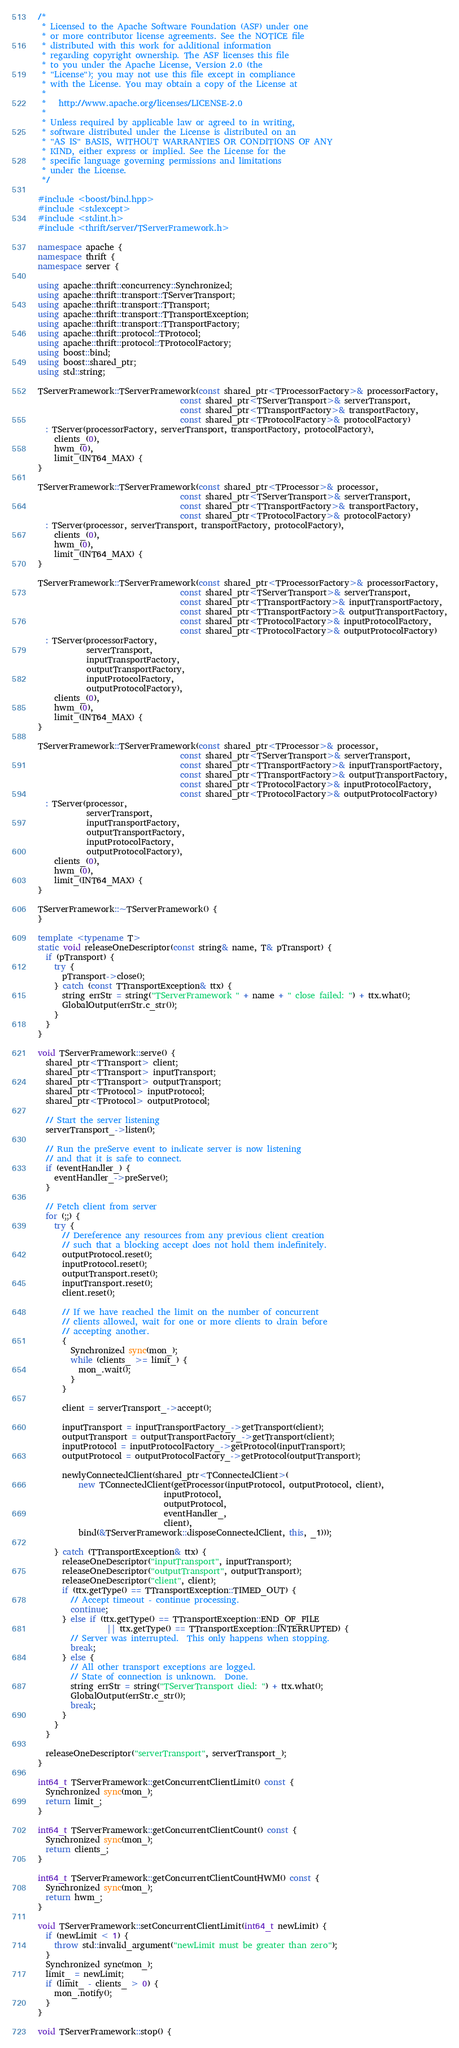Convert code to text. <code><loc_0><loc_0><loc_500><loc_500><_C++_>/*
 * Licensed to the Apache Software Foundation (ASF) under one
 * or more contributor license agreements. See the NOTICE file
 * distributed with this work for additional information
 * regarding copyright ownership. The ASF licenses this file
 * to you under the Apache License, Version 2.0 (the
 * "License"); you may not use this file except in compliance
 * with the License. You may obtain a copy of the License at
 *
 *   http://www.apache.org/licenses/LICENSE-2.0
 *
 * Unless required by applicable law or agreed to in writing,
 * software distributed under the License is distributed on an
 * "AS IS" BASIS, WITHOUT WARRANTIES OR CONDITIONS OF ANY
 * KIND, either express or implied. See the License for the
 * specific language governing permissions and limitations
 * under the License.
 */

#include <boost/bind.hpp>
#include <stdexcept>
#include <stdint.h>
#include <thrift/server/TServerFramework.h>

namespace apache {
namespace thrift {
namespace server {

using apache::thrift::concurrency::Synchronized;
using apache::thrift::transport::TServerTransport;
using apache::thrift::transport::TTransport;
using apache::thrift::transport::TTransportException;
using apache::thrift::transport::TTransportFactory;
using apache::thrift::protocol::TProtocol;
using apache::thrift::protocol::TProtocolFactory;
using boost::bind;
using boost::shared_ptr;
using std::string;

TServerFramework::TServerFramework(const shared_ptr<TProcessorFactory>& processorFactory,
                                   const shared_ptr<TServerTransport>& serverTransport,
                                   const shared_ptr<TTransportFactory>& transportFactory,
                                   const shared_ptr<TProtocolFactory>& protocolFactory)
  : TServer(processorFactory, serverTransport, transportFactory, protocolFactory),
    clients_(0),
    hwm_(0),
    limit_(INT64_MAX) {
}

TServerFramework::TServerFramework(const shared_ptr<TProcessor>& processor,
                                   const shared_ptr<TServerTransport>& serverTransport,
                                   const shared_ptr<TTransportFactory>& transportFactory,
                                   const shared_ptr<TProtocolFactory>& protocolFactory)
  : TServer(processor, serverTransport, transportFactory, protocolFactory),
    clients_(0),
    hwm_(0),
    limit_(INT64_MAX) {
}

TServerFramework::TServerFramework(const shared_ptr<TProcessorFactory>& processorFactory,
                                   const shared_ptr<TServerTransport>& serverTransport,
                                   const shared_ptr<TTransportFactory>& inputTransportFactory,
                                   const shared_ptr<TTransportFactory>& outputTransportFactory,
                                   const shared_ptr<TProtocolFactory>& inputProtocolFactory,
                                   const shared_ptr<TProtocolFactory>& outputProtocolFactory)
  : TServer(processorFactory,
            serverTransport,
            inputTransportFactory,
            outputTransportFactory,
            inputProtocolFactory,
            outputProtocolFactory),
    clients_(0),
    hwm_(0),
    limit_(INT64_MAX) {
}

TServerFramework::TServerFramework(const shared_ptr<TProcessor>& processor,
                                   const shared_ptr<TServerTransport>& serverTransport,
                                   const shared_ptr<TTransportFactory>& inputTransportFactory,
                                   const shared_ptr<TTransportFactory>& outputTransportFactory,
                                   const shared_ptr<TProtocolFactory>& inputProtocolFactory,
                                   const shared_ptr<TProtocolFactory>& outputProtocolFactory)
  : TServer(processor,
            serverTransport,
            inputTransportFactory,
            outputTransportFactory,
            inputProtocolFactory,
            outputProtocolFactory),
    clients_(0),
    hwm_(0),
    limit_(INT64_MAX) {
}

TServerFramework::~TServerFramework() {
}

template <typename T>
static void releaseOneDescriptor(const string& name, T& pTransport) {
  if (pTransport) {
    try {
      pTransport->close();
    } catch (const TTransportException& ttx) {
      string errStr = string("TServerFramework " + name + " close failed: ") + ttx.what();
      GlobalOutput(errStr.c_str());
    }
  }
}

void TServerFramework::serve() {
  shared_ptr<TTransport> client;
  shared_ptr<TTransport> inputTransport;
  shared_ptr<TTransport> outputTransport;
  shared_ptr<TProtocol> inputProtocol;
  shared_ptr<TProtocol> outputProtocol;

  // Start the server listening
  serverTransport_->listen();

  // Run the preServe event to indicate server is now listening
  // and that it is safe to connect.
  if (eventHandler_) {
    eventHandler_->preServe();
  }

  // Fetch client from server
  for (;;) {
    try {
      // Dereference any resources from any previous client creation
      // such that a blocking accept does not hold them indefinitely.
      outputProtocol.reset();
      inputProtocol.reset();
      outputTransport.reset();
      inputTransport.reset();
      client.reset();

      // If we have reached the limit on the number of concurrent
      // clients allowed, wait for one or more clients to drain before
      // accepting another.
      {
        Synchronized sync(mon_);
        while (clients_ >= limit_) {
          mon_.wait();
        }
      }

      client = serverTransport_->accept();

      inputTransport = inputTransportFactory_->getTransport(client);
      outputTransport = outputTransportFactory_->getTransport(client);
      inputProtocol = inputProtocolFactory_->getProtocol(inputTransport);
      outputProtocol = outputProtocolFactory_->getProtocol(outputTransport);

      newlyConnectedClient(shared_ptr<TConnectedClient>(
          new TConnectedClient(getProcessor(inputProtocol, outputProtocol, client),
                               inputProtocol,
                               outputProtocol,
                               eventHandler_,
                               client),
          bind(&TServerFramework::disposeConnectedClient, this, _1)));

    } catch (TTransportException& ttx) {
      releaseOneDescriptor("inputTransport", inputTransport);
      releaseOneDescriptor("outputTransport", outputTransport);
      releaseOneDescriptor("client", client);
      if (ttx.getType() == TTransportException::TIMED_OUT) {
        // Accept timeout - continue processing.
        continue;
      } else if (ttx.getType() == TTransportException::END_OF_FILE
                 || ttx.getType() == TTransportException::INTERRUPTED) {
        // Server was interrupted.  This only happens when stopping.
        break;
      } else {
        // All other transport exceptions are logged.
        // State of connection is unknown.  Done.
        string errStr = string("TServerTransport died: ") + ttx.what();
        GlobalOutput(errStr.c_str());
        break;
      }
    }
  }

  releaseOneDescriptor("serverTransport", serverTransport_);
}

int64_t TServerFramework::getConcurrentClientLimit() const {
  Synchronized sync(mon_);
  return limit_;
}

int64_t TServerFramework::getConcurrentClientCount() const {
  Synchronized sync(mon_);
  return clients_;
}

int64_t TServerFramework::getConcurrentClientCountHWM() const {
  Synchronized sync(mon_);
  return hwm_;
}

void TServerFramework::setConcurrentClientLimit(int64_t newLimit) {
  if (newLimit < 1) {
    throw std::invalid_argument("newLimit must be greater than zero");
  }
  Synchronized sync(mon_);
  limit_ = newLimit;
  if (limit_ - clients_ > 0) {
    mon_.notify();
  }
}

void TServerFramework::stop() {</code> 